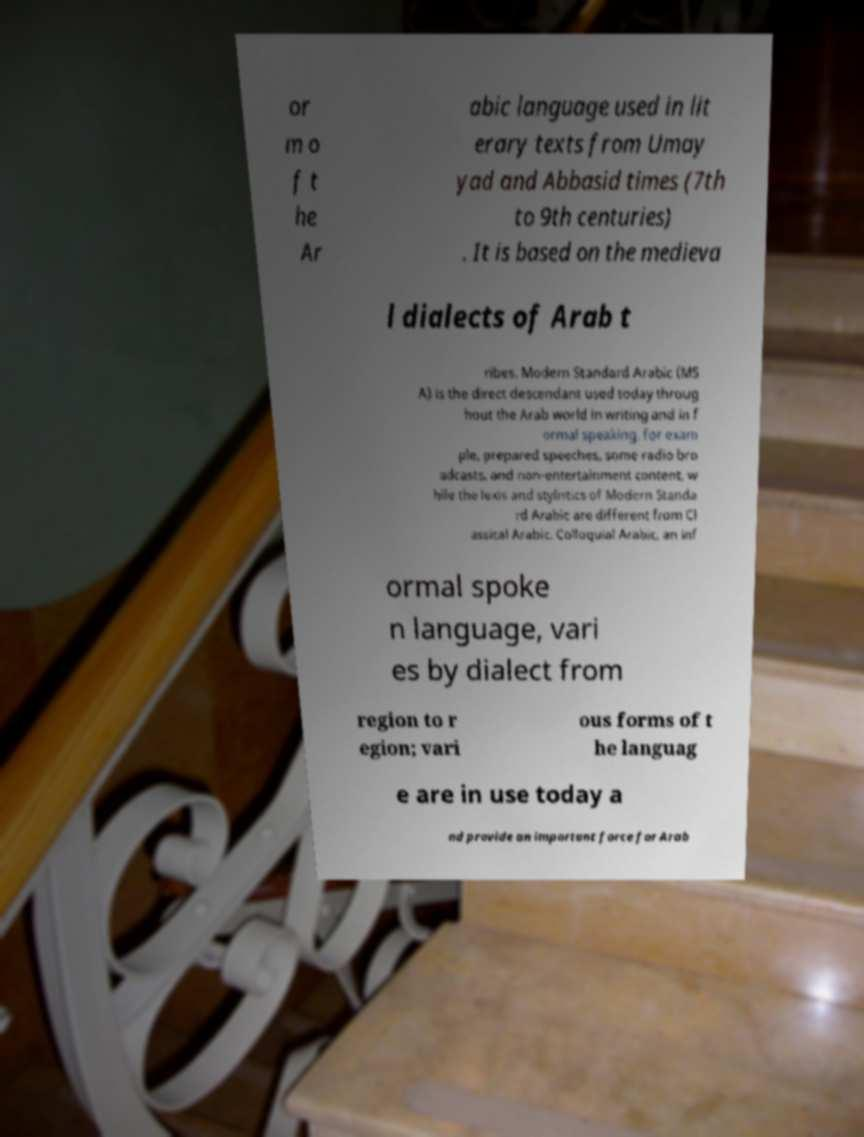Can you accurately transcribe the text from the provided image for me? or m o f t he Ar abic language used in lit erary texts from Umay yad and Abbasid times (7th to 9th centuries) . It is based on the medieva l dialects of Arab t ribes. Modern Standard Arabic (MS A) is the direct descendant used today throug hout the Arab world in writing and in f ormal speaking, for exam ple, prepared speeches, some radio bro adcasts, and non-entertainment content, w hile the lexis and stylistics of Modern Standa rd Arabic are different from Cl assical Arabic. Colloquial Arabic, an inf ormal spoke n language, vari es by dialect from region to r egion; vari ous forms of t he languag e are in use today a nd provide an important force for Arab 